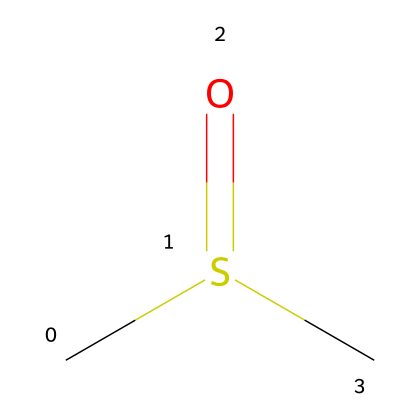What is the molecular formula of this compound? The SMILES representation shows two carbon atoms (C), one sulfur atom (S), and one oxygen atom (O), which together give the molecular formula as C2H6OS.
Answer: C2H6OS How many hydrogen atoms are present in the structure? The molecular structure indicates that there are six hydrogen atoms bonded to the two carbon atoms, as seen in the formula derived from the SMILES.
Answer: 6 What type of bond connects sulfur and oxygen in this molecule? The structural representation shows a double bond between sulfur (S) and oxygen (O), indicated by the '=' sign in the SMILES notation.
Answer: double bond How many total atoms are in this molecule? By counting the atoms given in the molecular formula (2 carbons, 6 hydrogens, 1 sulfur, and 1 oxygen), the total number is 10.
Answer: 10 What is the functional group present in dimethyl sulfoxide? The functional group in this compound is characterized by the presence of the sulfoxide moiety (R-S(=O)-R'), which contains the sulfur atom double-bonded to an oxygen atom.
Answer: sulfoxide Does this compound exhibit polarity? The presence of the sulfinyl (S=O) bond creates a polar environment due to the difference in electronegativity between sulfur and oxygen, making the molecule polar.
Answer: Yes What type of organosulfur compound is dimethyl sulfoxide classified as? Based on its structure and the presence of a sulfur atom bonded to oxygen (as in the sulfoxide functional group), this compound is classified as a sulfoxide.
Answer: sulfoxide 